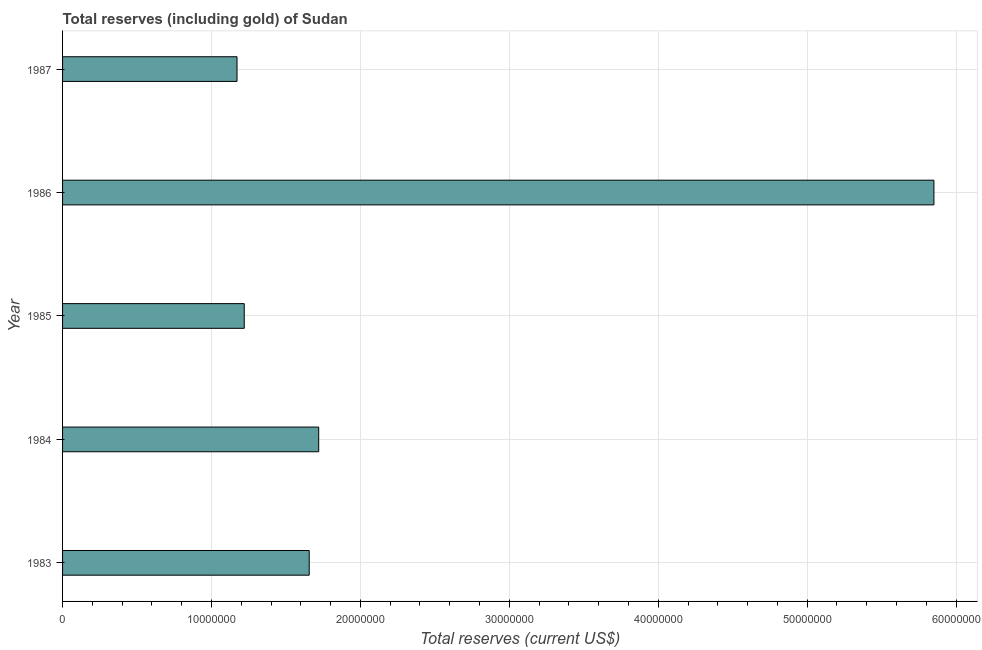Does the graph contain any zero values?
Your answer should be very brief. No. What is the title of the graph?
Ensure brevity in your answer.  Total reserves (including gold) of Sudan. What is the label or title of the X-axis?
Give a very brief answer. Total reserves (current US$). What is the label or title of the Y-axis?
Provide a short and direct response. Year. What is the total reserves (including gold) in 1983?
Your response must be concise. 1.66e+07. Across all years, what is the maximum total reserves (including gold)?
Give a very brief answer. 5.85e+07. Across all years, what is the minimum total reserves (including gold)?
Offer a terse response. 1.17e+07. In which year was the total reserves (including gold) maximum?
Ensure brevity in your answer.  1986. In which year was the total reserves (including gold) minimum?
Keep it short and to the point. 1987. What is the sum of the total reserves (including gold)?
Keep it short and to the point. 1.16e+08. What is the difference between the total reserves (including gold) in 1984 and 1987?
Your answer should be very brief. 5.49e+06. What is the average total reserves (including gold) per year?
Offer a terse response. 2.32e+07. What is the median total reserves (including gold)?
Provide a short and direct response. 1.66e+07. Do a majority of the years between 1987 and 1984 (inclusive) have total reserves (including gold) greater than 10000000 US$?
Keep it short and to the point. Yes. What is the ratio of the total reserves (including gold) in 1985 to that in 1986?
Your response must be concise. 0.21. Is the total reserves (including gold) in 1984 less than that in 1986?
Provide a succinct answer. Yes. What is the difference between the highest and the second highest total reserves (including gold)?
Give a very brief answer. 4.13e+07. Is the sum of the total reserves (including gold) in 1983 and 1987 greater than the maximum total reserves (including gold) across all years?
Offer a very short reply. No. What is the difference between the highest and the lowest total reserves (including gold)?
Provide a succinct answer. 4.68e+07. In how many years, is the total reserves (including gold) greater than the average total reserves (including gold) taken over all years?
Offer a very short reply. 1. How many years are there in the graph?
Provide a succinct answer. 5. What is the Total reserves (current US$) in 1983?
Keep it short and to the point. 1.66e+07. What is the Total reserves (current US$) in 1984?
Offer a very short reply. 1.72e+07. What is the Total reserves (current US$) in 1985?
Offer a terse response. 1.22e+07. What is the Total reserves (current US$) in 1986?
Offer a very short reply. 5.85e+07. What is the Total reserves (current US$) of 1987?
Your response must be concise. 1.17e+07. What is the difference between the Total reserves (current US$) in 1983 and 1984?
Keep it short and to the point. -6.37e+05. What is the difference between the Total reserves (current US$) in 1983 and 1985?
Ensure brevity in your answer.  4.36e+06. What is the difference between the Total reserves (current US$) in 1983 and 1986?
Provide a short and direct response. -4.19e+07. What is the difference between the Total reserves (current US$) in 1983 and 1987?
Ensure brevity in your answer.  4.85e+06. What is the difference between the Total reserves (current US$) in 1984 and 1986?
Keep it short and to the point. -4.13e+07. What is the difference between the Total reserves (current US$) in 1984 and 1987?
Offer a very short reply. 5.49e+06. What is the difference between the Total reserves (current US$) in 1985 and 1986?
Provide a short and direct response. -4.63e+07. What is the difference between the Total reserves (current US$) in 1985 and 1987?
Your response must be concise. 4.86e+05. What is the difference between the Total reserves (current US$) in 1986 and 1987?
Give a very brief answer. 4.68e+07. What is the ratio of the Total reserves (current US$) in 1983 to that in 1985?
Offer a very short reply. 1.36. What is the ratio of the Total reserves (current US$) in 1983 to that in 1986?
Keep it short and to the point. 0.28. What is the ratio of the Total reserves (current US$) in 1983 to that in 1987?
Provide a short and direct response. 1.41. What is the ratio of the Total reserves (current US$) in 1984 to that in 1985?
Offer a terse response. 1.41. What is the ratio of the Total reserves (current US$) in 1984 to that in 1986?
Your answer should be compact. 0.29. What is the ratio of the Total reserves (current US$) in 1984 to that in 1987?
Keep it short and to the point. 1.47. What is the ratio of the Total reserves (current US$) in 1985 to that in 1986?
Offer a very short reply. 0.21. What is the ratio of the Total reserves (current US$) in 1985 to that in 1987?
Ensure brevity in your answer.  1.04. What is the ratio of the Total reserves (current US$) in 1986 to that in 1987?
Provide a short and direct response. 5. 